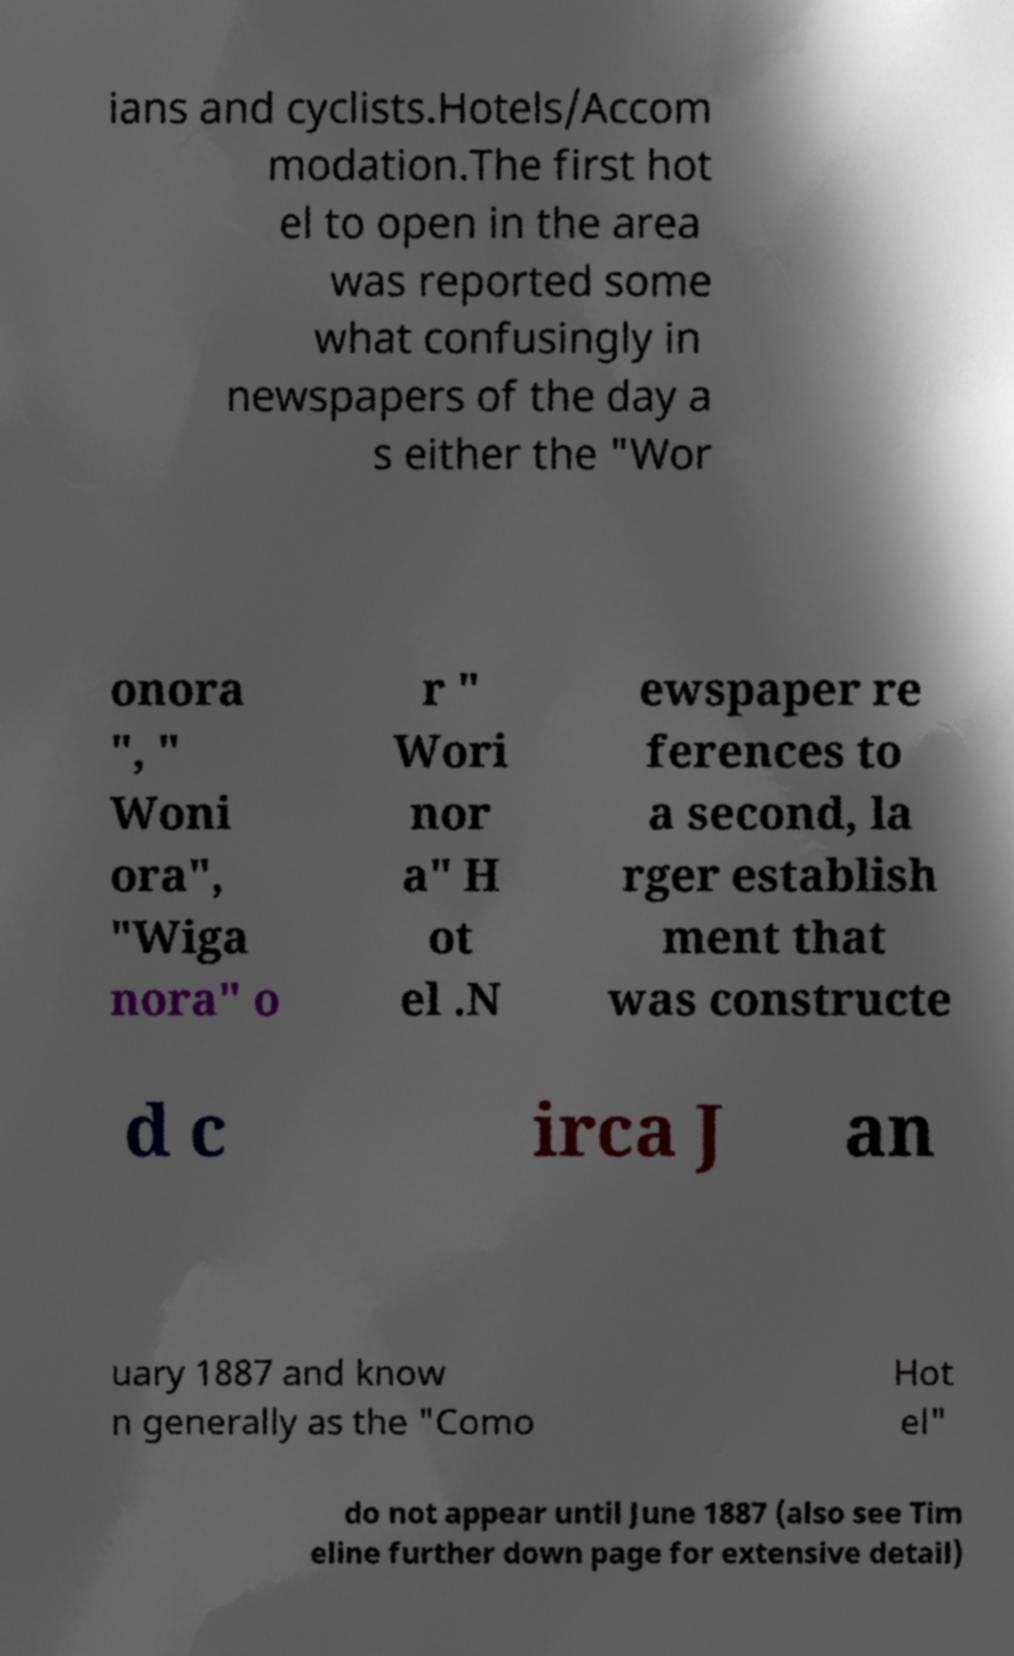Can you accurately transcribe the text from the provided image for me? ians and cyclists.Hotels/Accom modation.The first hot el to open in the area was reported some what confusingly in newspapers of the day a s either the "Wor onora ", " Woni ora", "Wiga nora" o r " Wori nor a" H ot el .N ewspaper re ferences to a second, la rger establish ment that was constructe d c irca J an uary 1887 and know n generally as the "Como Hot el" do not appear until June 1887 (also see Tim eline further down page for extensive detail) 